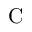<formula> <loc_0><loc_0><loc_500><loc_500>C</formula> 